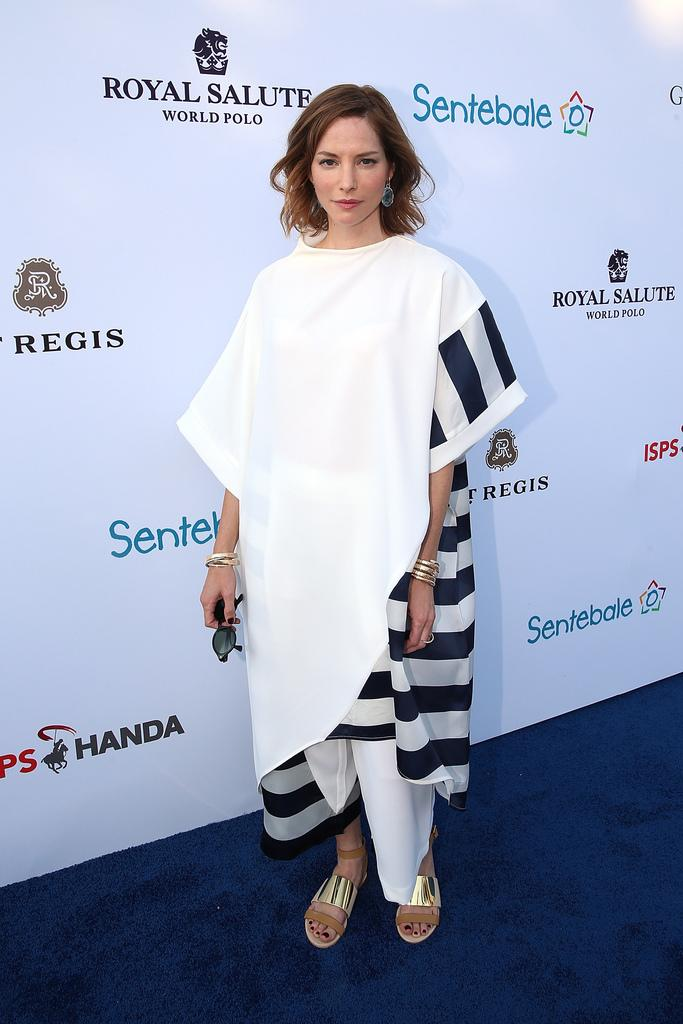Who is present in the image? There is a woman in the image. What is the woman doing in the image? The woman is standing in the image. What object is the woman holding? The woman is holding goggles. What can be seen in the background of the image? There is text and logos visible in the background of the image. What type of humor can be seen in the woman's facial expression in the image? There is no indication of humor or facial expression in the image; it only shows the woman standing and holding goggles. 